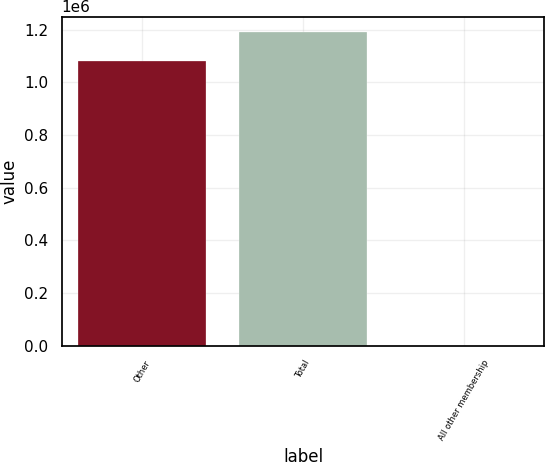<chart> <loc_0><loc_0><loc_500><loc_500><bar_chart><fcel>Other<fcel>Total<fcel>All other membership<nl><fcel>1.0824e+06<fcel>1.19063e+06<fcel>100<nl></chart> 